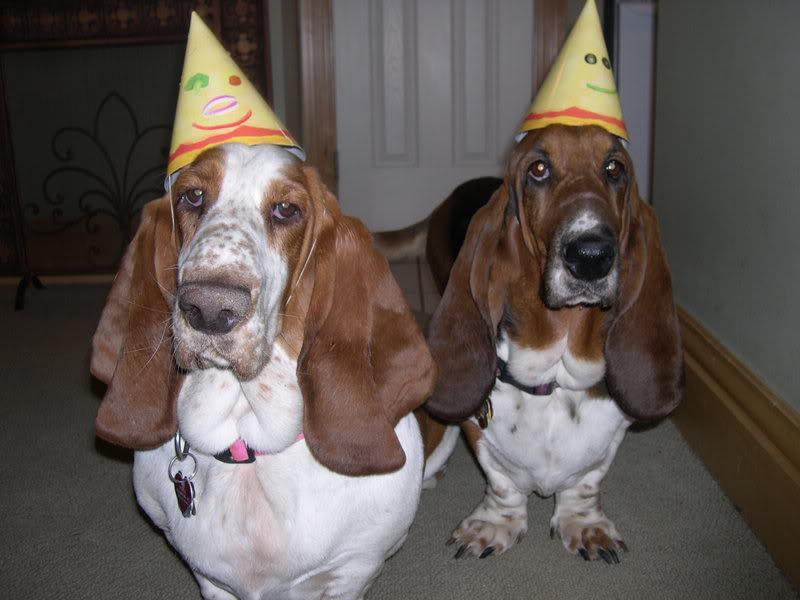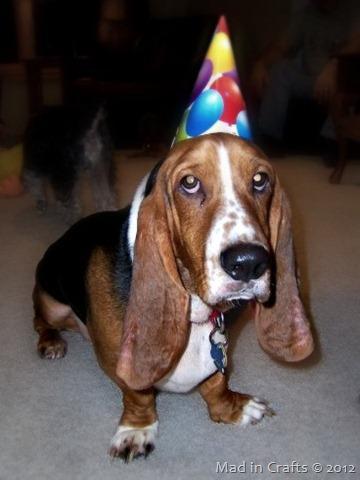The first image is the image on the left, the second image is the image on the right. Analyze the images presented: Is the assertion "One of the dogs is lying on a couch." valid? Answer yes or no. No. 